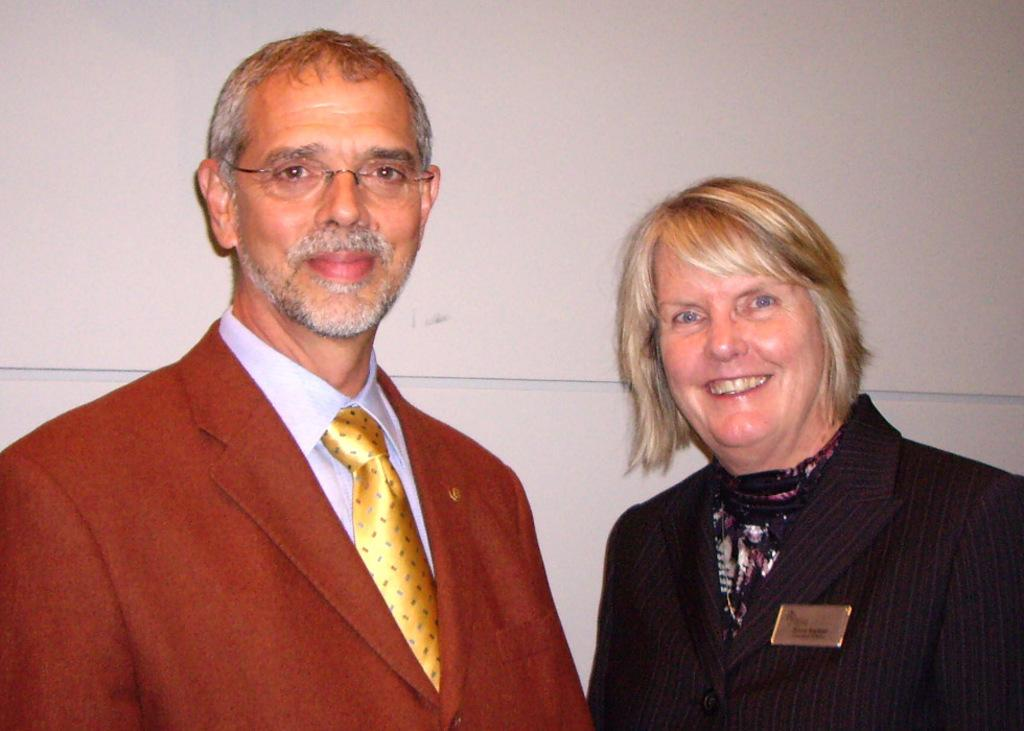Who is present in the image? There is a man and a woman in the image. What are the expressions of the people in the image? Both the man and the woman are smiling. What can be seen on the man's face? The man is wearing spectacles. What is visible in the background of the image? There is a wall in the background of the image. What type of hammer is the man holding in the image? There is no hammer present in the image; the man is not holding any tool. 